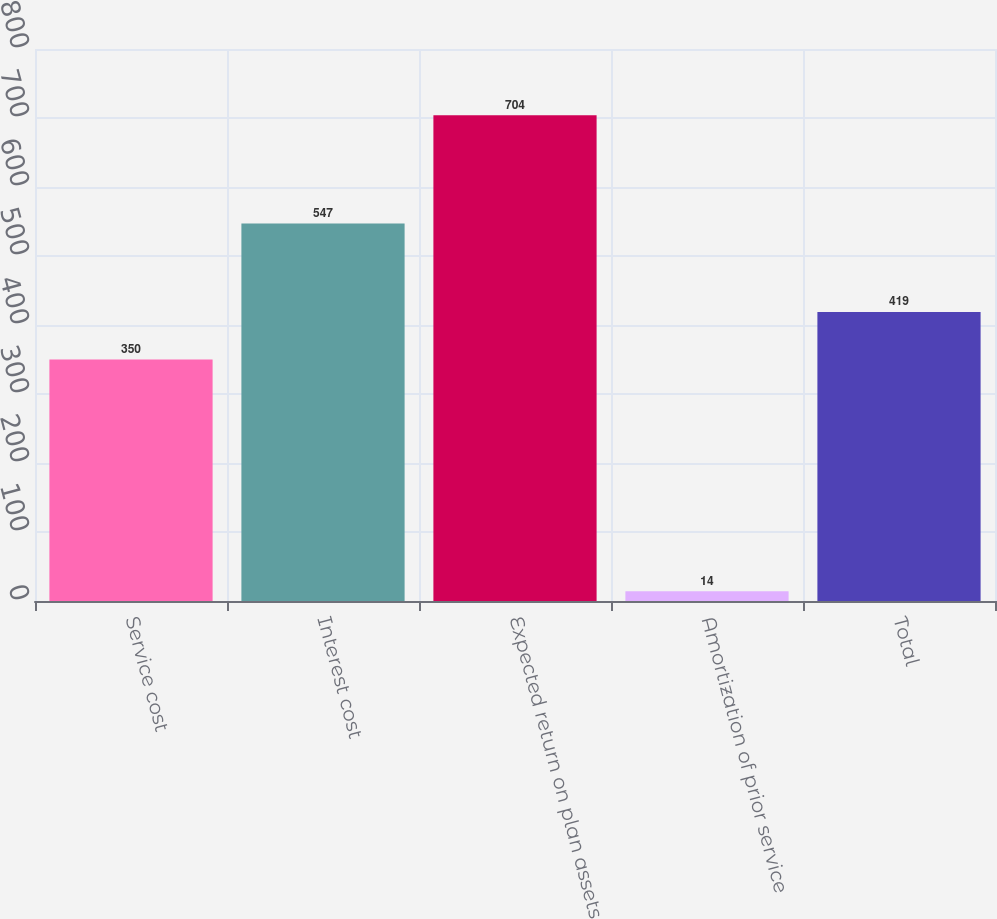Convert chart to OTSL. <chart><loc_0><loc_0><loc_500><loc_500><bar_chart><fcel>Service cost<fcel>Interest cost<fcel>Expected return on plan assets<fcel>Amortization of prior service<fcel>Total<nl><fcel>350<fcel>547<fcel>704<fcel>14<fcel>419<nl></chart> 